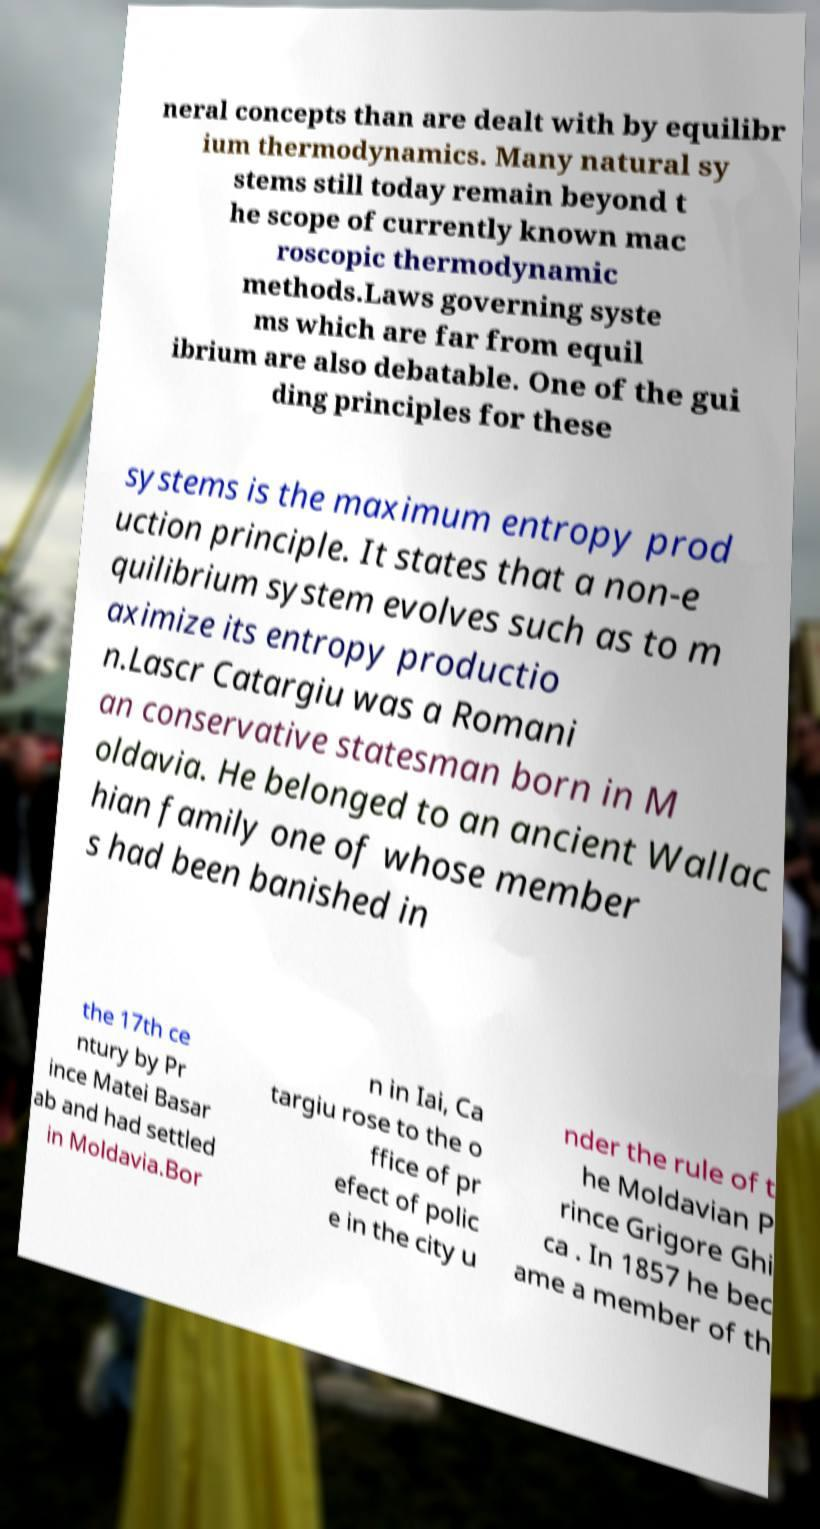Can you accurately transcribe the text from the provided image for me? neral concepts than are dealt with by equilibr ium thermodynamics. Many natural sy stems still today remain beyond t he scope of currently known mac roscopic thermodynamic methods.Laws governing syste ms which are far from equil ibrium are also debatable. One of the gui ding principles for these systems is the maximum entropy prod uction principle. It states that a non-e quilibrium system evolves such as to m aximize its entropy productio n.Lascr Catargiu was a Romani an conservative statesman born in M oldavia. He belonged to an ancient Wallac hian family one of whose member s had been banished in the 17th ce ntury by Pr ince Matei Basar ab and had settled in Moldavia.Bor n in Iai, Ca targiu rose to the o ffice of pr efect of polic e in the city u nder the rule of t he Moldavian P rince Grigore Ghi ca . In 1857 he bec ame a member of th 